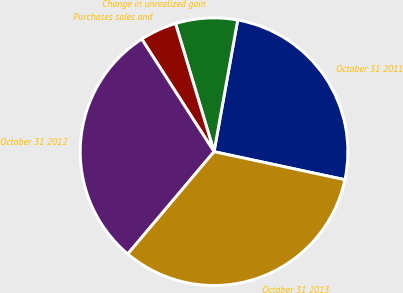Convert chart to OTSL. <chart><loc_0><loc_0><loc_500><loc_500><pie_chart><fcel>October 31 2011<fcel>Change in unrealized gain<fcel>Purchases sales and<fcel>October 31 2012<fcel>October 31 2013<nl><fcel>25.53%<fcel>7.47%<fcel>4.44%<fcel>29.76%<fcel>32.79%<nl></chart> 